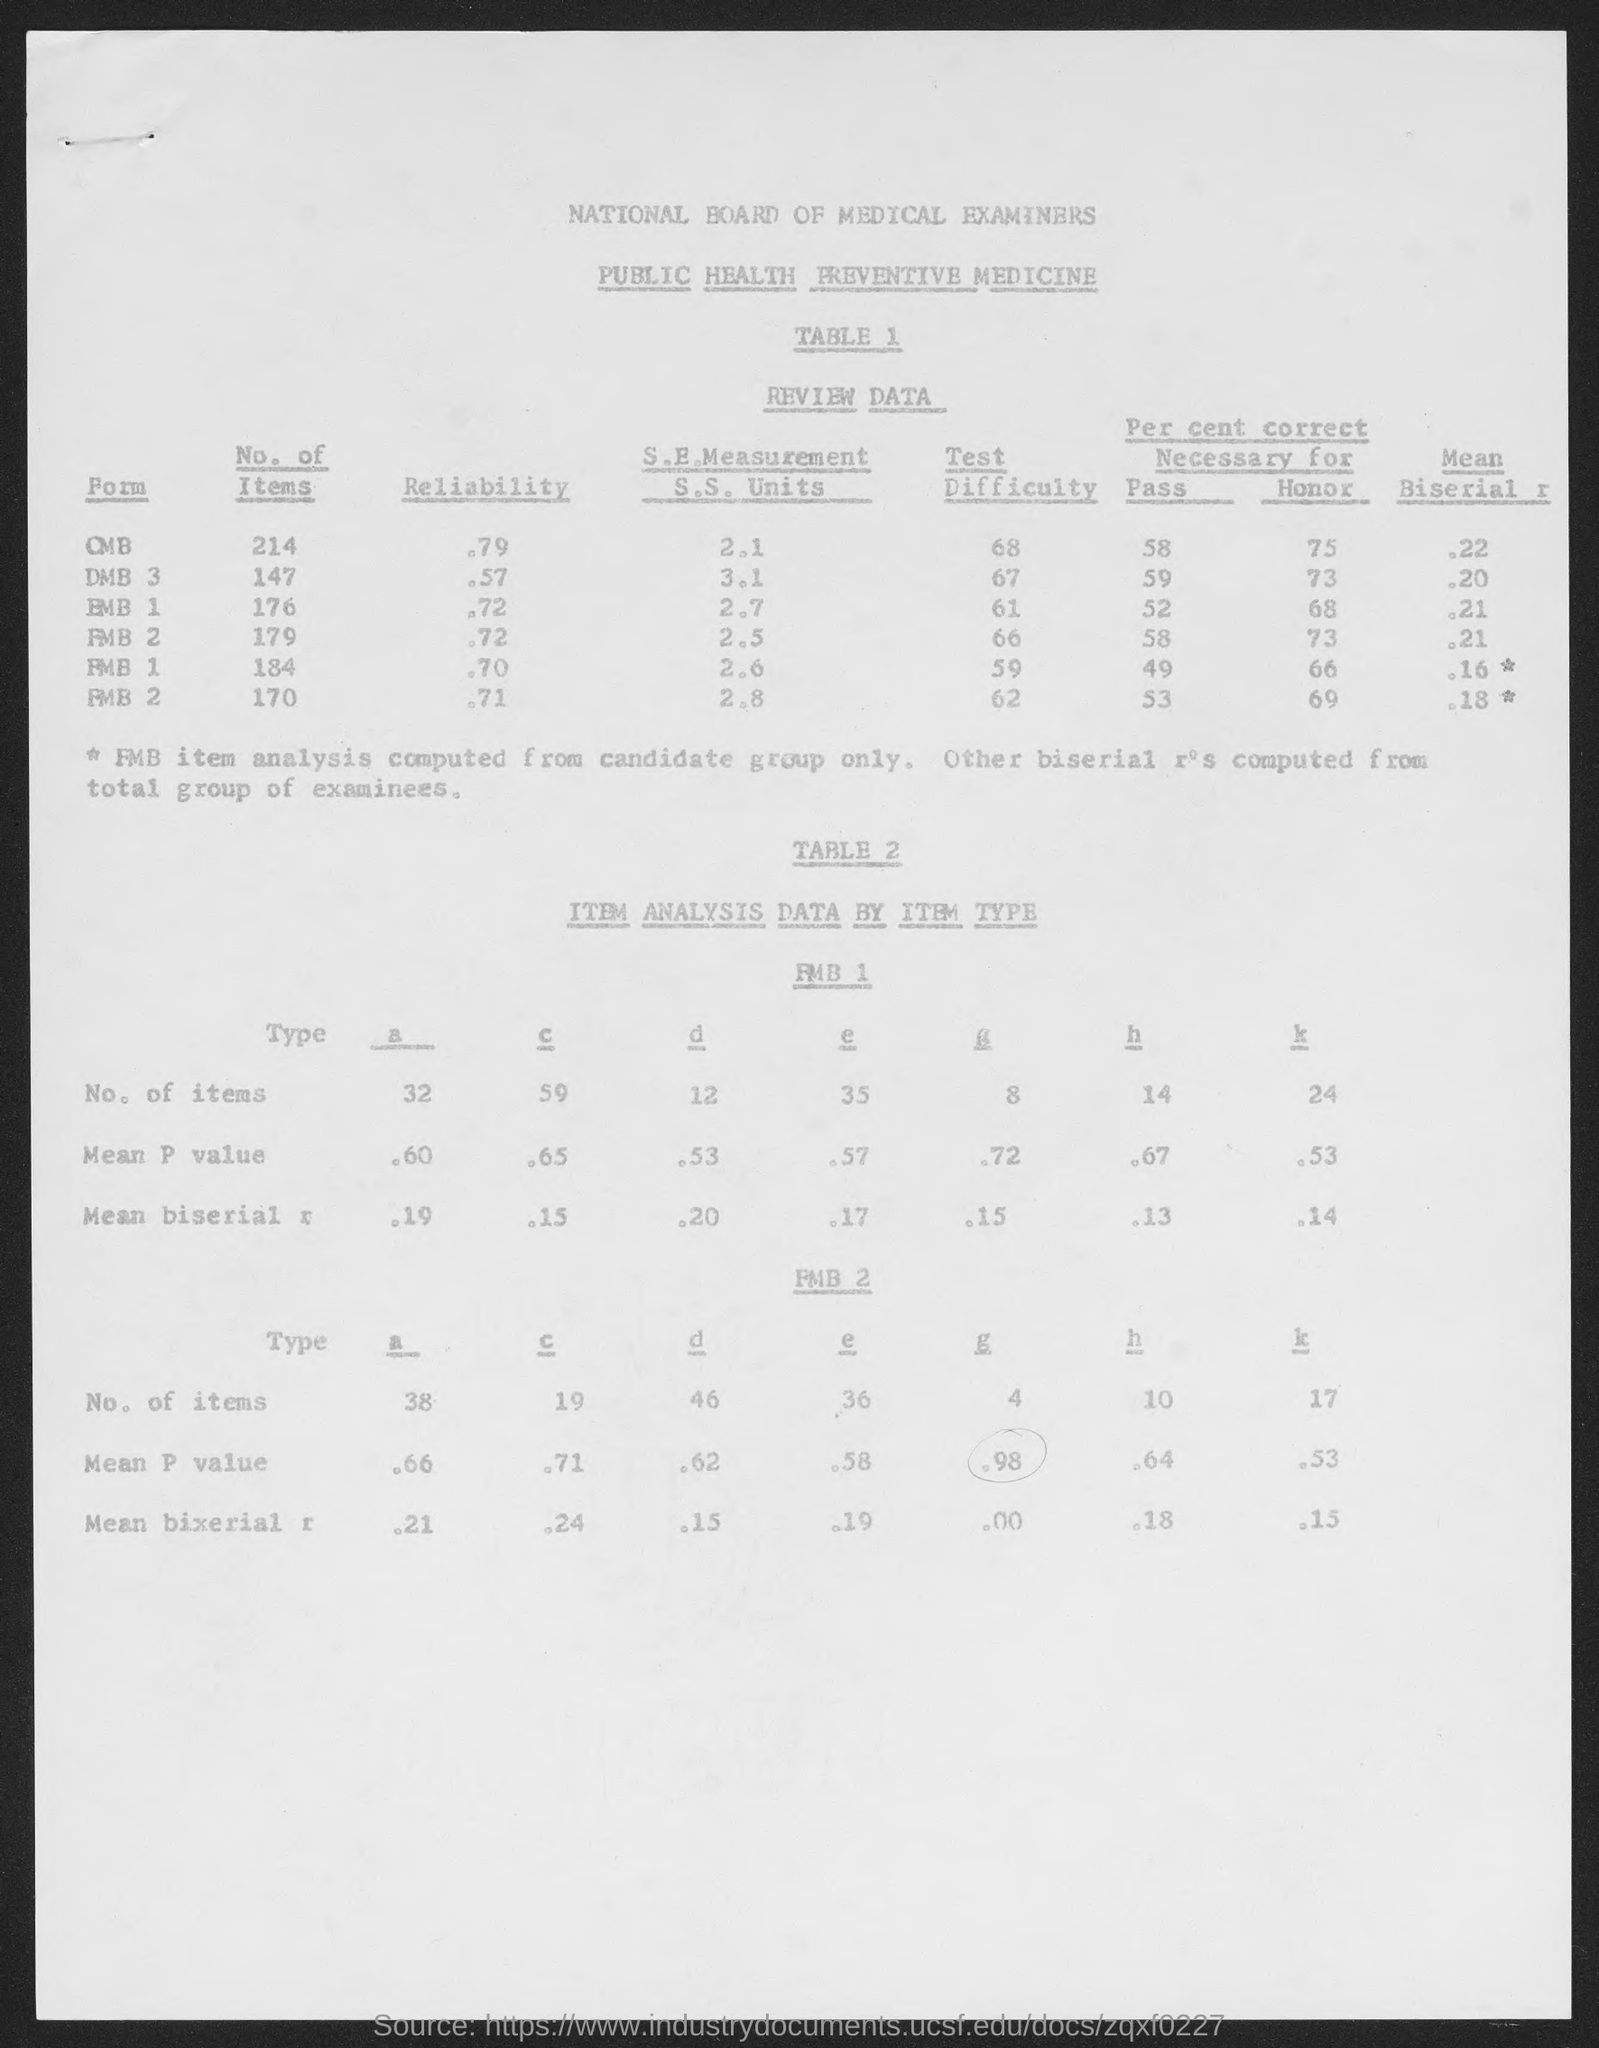What is the first form ?
Give a very brief answer. OMB. How many no of items did form " OMB" has?
Give a very brief answer. 214. How many no of items are there for type "a" for the table FMB 1?
Ensure brevity in your answer.  32. Which board examines the public health?
Provide a succinct answer. National board of medical examiners. How much is the test difficulty of form " DMB 3 " in Table 1 ?
Ensure brevity in your answer.  67. What is the heading of the Table 2 ?
Keep it short and to the point. ITEM ANALYSIS DATA BY ITEM TYPE. 